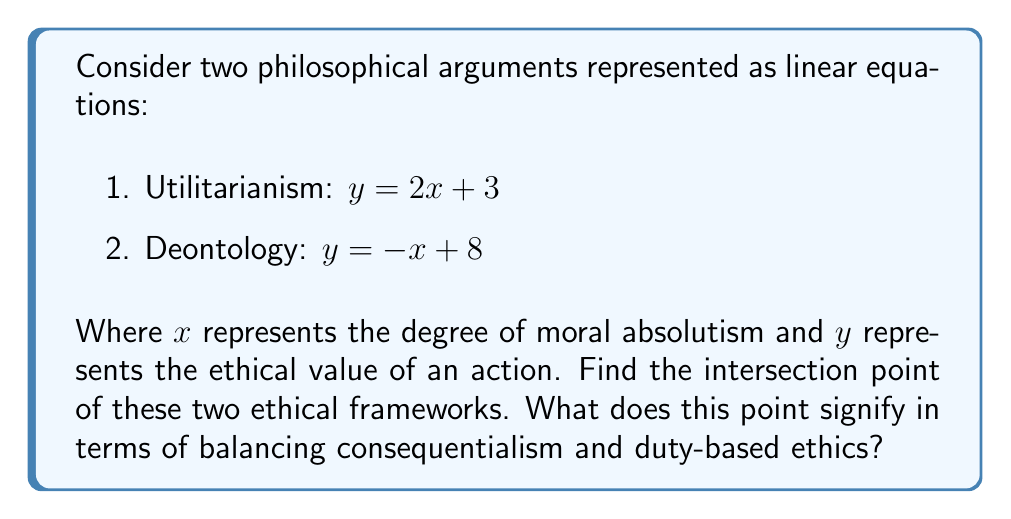Give your solution to this math problem. To find the intersection point of these two philosophical arguments, we need to solve the system of equations:

$$\begin{cases}
y = 2x + 3 \\
y = -x + 8
\end{cases}$$

Step 1: Set the equations equal to each other since they intersect at a point where y is equal for both.
$2x + 3 = -x + 8$

Step 2: Solve for x by adding x to both sides and subtracting 3 from both sides.
$3x = 5$
$x = \frac{5}{3}$

Step 3: Substitute this x-value into either of the original equations to find y. Let's use the Utilitarianism equation:
$y = 2(\frac{5}{3}) + 3$
$y = \frac{10}{3} + 3$
$y = \frac{10}{3} + \frac{9}{3}$
$y = \frac{19}{3}$

Therefore, the intersection point is $(\frac{5}{3}, \frac{19}{3})$.

This point signifies a balance between utilitarianism and deontology. At $x = \frac{5}{3}$, we have a moderate degree of moral absolutism. The $y$-value of $\frac{19}{3}$ represents the ethical value where both frameworks agree, suggesting a compromise between consequentialist and duty-based ethics.
Answer: $(\frac{5}{3}, \frac{19}{3})$ 